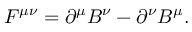Convert formula to latex. <formula><loc_0><loc_0><loc_500><loc_500>F ^ { \mu \nu } = \partial ^ { \mu } B ^ { \nu } - \partial ^ { \nu } B ^ { \mu } .</formula> 